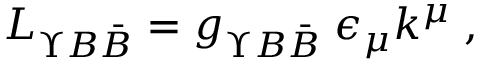<formula> <loc_0><loc_0><loc_500><loc_500>L _ { \Upsilon B \bar { B } } = g _ { \Upsilon B \bar { B } } \, \epsilon _ { \mu } k ^ { \mu } \, ,</formula> 